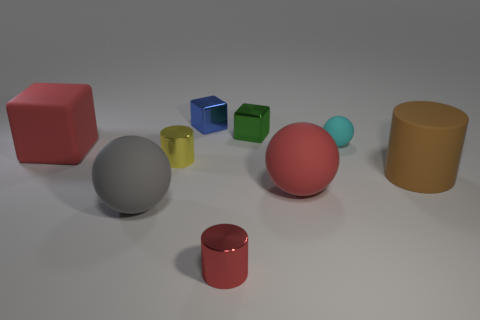Add 1 cyan rubber balls. How many objects exist? 10 Subtract all gray spheres. How many spheres are left? 2 Subtract all small blue metallic cubes. How many cubes are left? 2 Subtract all brown cylinders. How many green spheres are left? 0 Subtract all gray rubber cubes. Subtract all rubber cylinders. How many objects are left? 8 Add 8 small rubber spheres. How many small rubber spheres are left? 9 Add 8 shiny cylinders. How many shiny cylinders exist? 10 Subtract 0 purple cylinders. How many objects are left? 9 Subtract all balls. How many objects are left? 6 Subtract 1 cylinders. How many cylinders are left? 2 